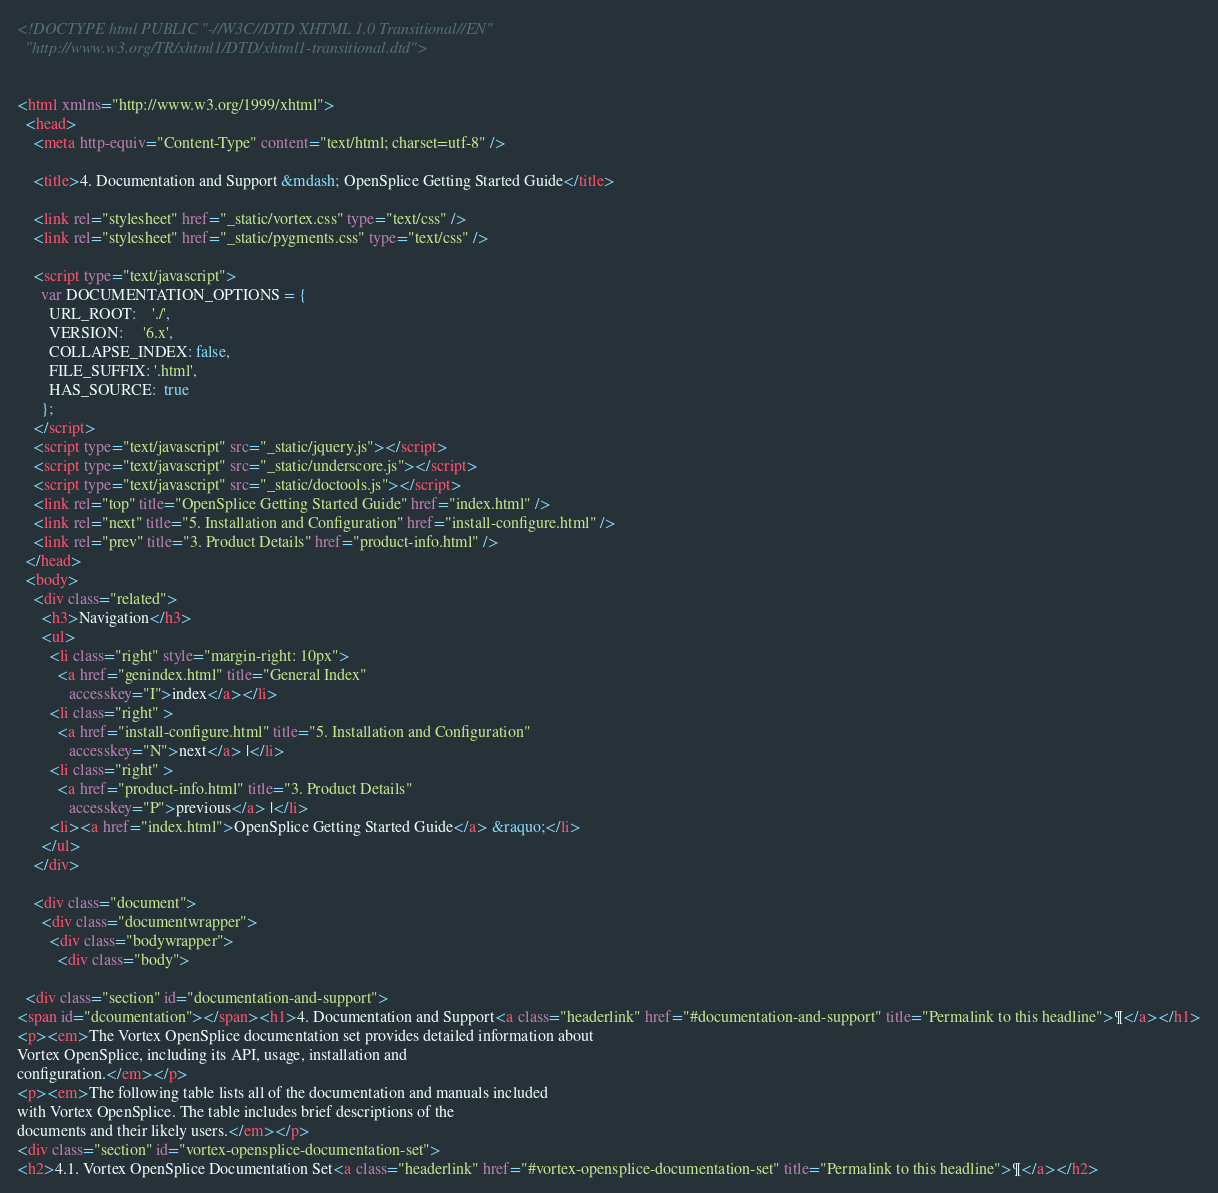<code> <loc_0><loc_0><loc_500><loc_500><_HTML_><!DOCTYPE html PUBLIC "-//W3C//DTD XHTML 1.0 Transitional//EN"
  "http://www.w3.org/TR/xhtml1/DTD/xhtml1-transitional.dtd">


<html xmlns="http://www.w3.org/1999/xhtml">
  <head>
    <meta http-equiv="Content-Type" content="text/html; charset=utf-8" />
    
    <title>4. Documentation and Support &mdash; OpenSplice Getting Started Guide</title>
    
    <link rel="stylesheet" href="_static/vortex.css" type="text/css" />
    <link rel="stylesheet" href="_static/pygments.css" type="text/css" />
    
    <script type="text/javascript">
      var DOCUMENTATION_OPTIONS = {
        URL_ROOT:    './',
        VERSION:     '6.x',
        COLLAPSE_INDEX: false,
        FILE_SUFFIX: '.html',
        HAS_SOURCE:  true
      };
    </script>
    <script type="text/javascript" src="_static/jquery.js"></script>
    <script type="text/javascript" src="_static/underscore.js"></script>
    <script type="text/javascript" src="_static/doctools.js"></script>
    <link rel="top" title="OpenSplice Getting Started Guide" href="index.html" />
    <link rel="next" title="5. Installation and Configuration" href="install-configure.html" />
    <link rel="prev" title="3. Product Details" href="product-info.html" /> 
  </head>
  <body>
    <div class="related">
      <h3>Navigation</h3>
      <ul>
        <li class="right" style="margin-right: 10px">
          <a href="genindex.html" title="General Index"
             accesskey="I">index</a></li>
        <li class="right" >
          <a href="install-configure.html" title="5. Installation and Configuration"
             accesskey="N">next</a> |</li>
        <li class="right" >
          <a href="product-info.html" title="3. Product Details"
             accesskey="P">previous</a> |</li>
        <li><a href="index.html">OpenSplice Getting Started Guide</a> &raquo;</li> 
      </ul>
    </div>  

    <div class="document">
      <div class="documentwrapper">
        <div class="bodywrapper">
          <div class="body">
            
  <div class="section" id="documentation-and-support">
<span id="dcoumentation"></span><h1>4. Documentation and Support<a class="headerlink" href="#documentation-and-support" title="Permalink to this headline">¶</a></h1>
<p><em>The Vortex OpenSplice documentation set provides detailed information about
Vortex OpenSplice, including its API, usage, installation and
configuration.</em></p>
<p><em>The following table lists all of the documentation and manuals included
with Vortex OpenSplice. The table includes brief descriptions of the
documents and their likely users.</em></p>
<div class="section" id="vortex-opensplice-documentation-set">
<h2>4.1. Vortex OpenSplice Documentation Set<a class="headerlink" href="#vortex-opensplice-documentation-set" title="Permalink to this headline">¶</a></h2></code> 